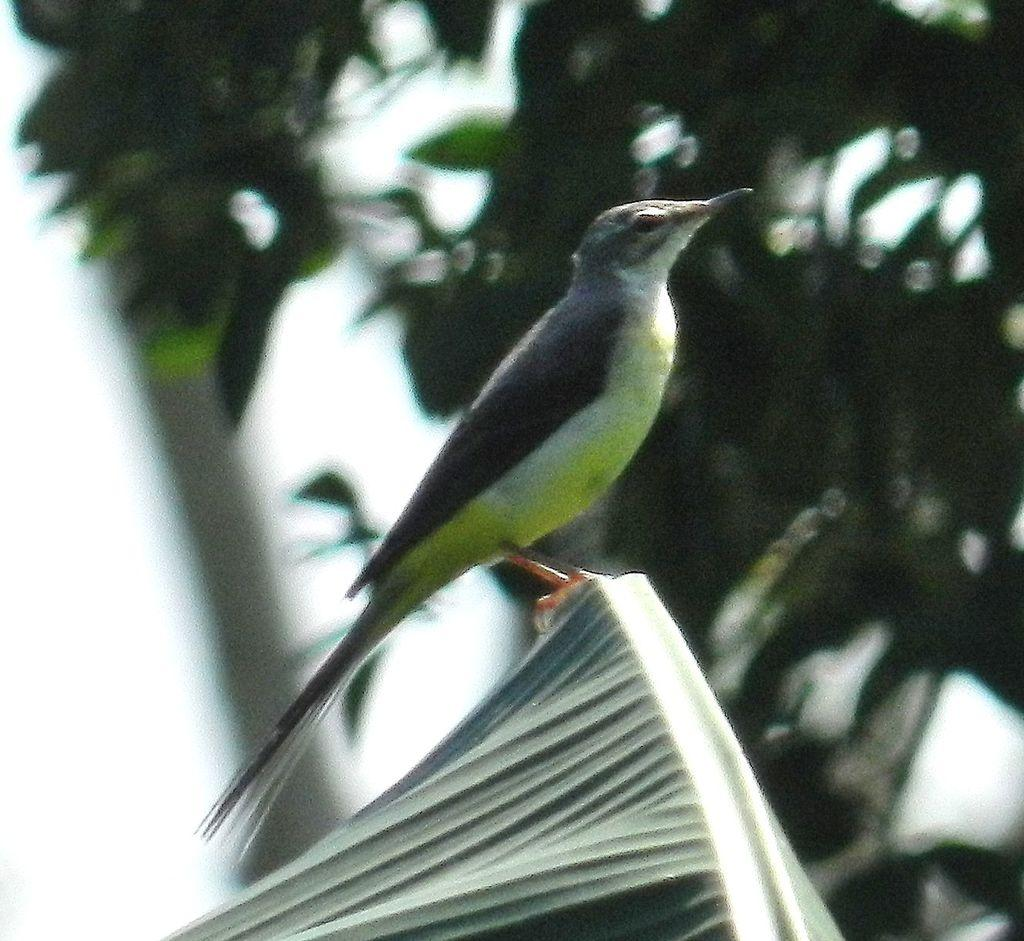What type of animal can be seen in the image? There is a bird in the image. Where is the bird located? The bird is on a leaf. What can be seen in the background of the image? There is a tree in the background of the image. How is the tree depicted in the image? The tree is blurred. How many mice can be seen climbing the mountain in the image? There are no mice or mountains present in the image; it features a bird on a leaf with a blurred tree in the background. 